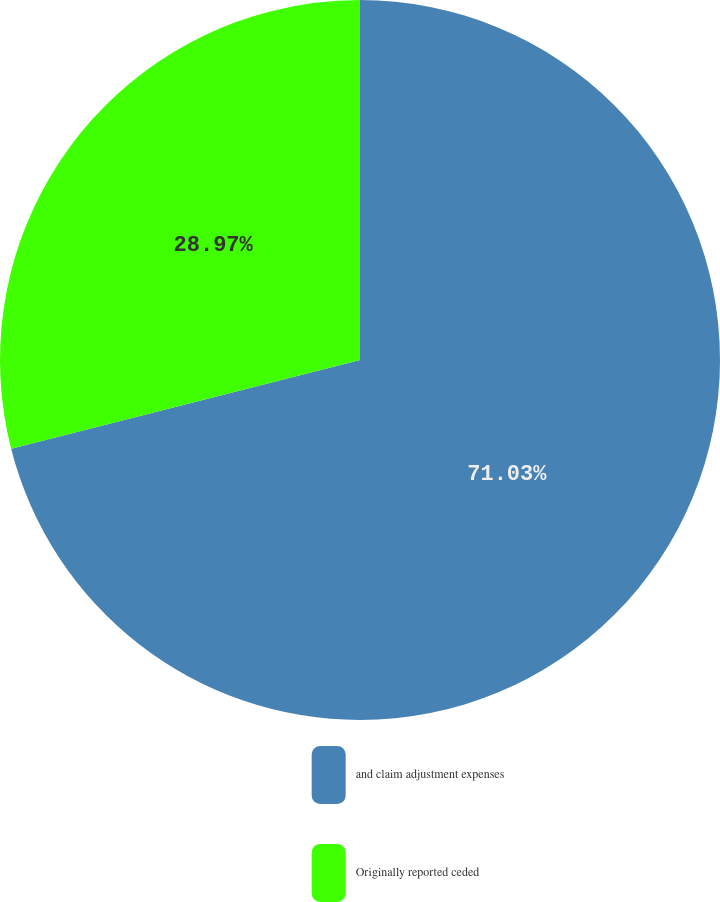Convert chart. <chart><loc_0><loc_0><loc_500><loc_500><pie_chart><fcel>and claim adjustment expenses<fcel>Originally reported ceded<nl><fcel>71.03%<fcel>28.97%<nl></chart> 